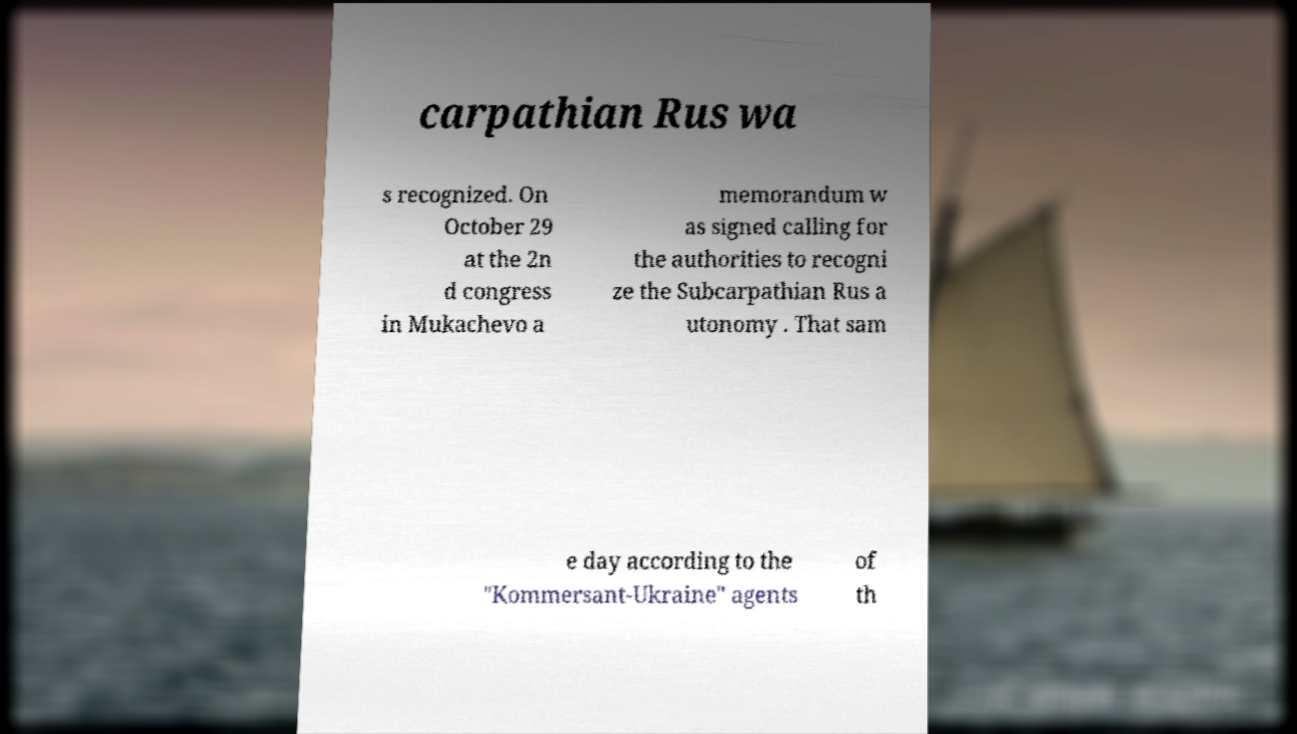There's text embedded in this image that I need extracted. Can you transcribe it verbatim? carpathian Rus wa s recognized. On October 29 at the 2n d congress in Mukachevo a memorandum w as signed calling for the authorities to recogni ze the Subcarpathian Rus a utonomy . That sam e day according to the "Kommersant-Ukraine" agents of th 